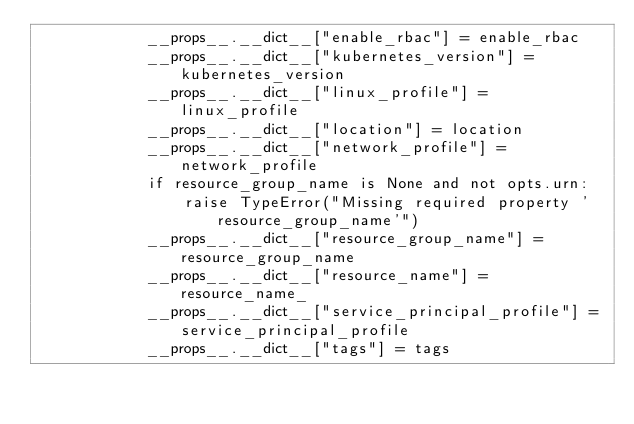<code> <loc_0><loc_0><loc_500><loc_500><_Python_>            __props__.__dict__["enable_rbac"] = enable_rbac
            __props__.__dict__["kubernetes_version"] = kubernetes_version
            __props__.__dict__["linux_profile"] = linux_profile
            __props__.__dict__["location"] = location
            __props__.__dict__["network_profile"] = network_profile
            if resource_group_name is None and not opts.urn:
                raise TypeError("Missing required property 'resource_group_name'")
            __props__.__dict__["resource_group_name"] = resource_group_name
            __props__.__dict__["resource_name"] = resource_name_
            __props__.__dict__["service_principal_profile"] = service_principal_profile
            __props__.__dict__["tags"] = tags</code> 